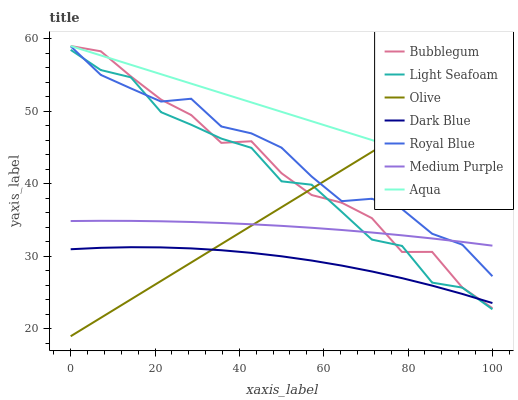Does Dark Blue have the minimum area under the curve?
Answer yes or no. Yes. Does Aqua have the maximum area under the curve?
Answer yes or no. Yes. Does Bubblegum have the minimum area under the curve?
Answer yes or no. No. Does Bubblegum have the maximum area under the curve?
Answer yes or no. No. Is Olive the smoothest?
Answer yes or no. Yes. Is Light Seafoam the roughest?
Answer yes or no. Yes. Is Aqua the smoothest?
Answer yes or no. No. Is Aqua the roughest?
Answer yes or no. No. Does Bubblegum have the lowest value?
Answer yes or no. No. Does Bubblegum have the highest value?
Answer yes or no. Yes. Does Medium Purple have the highest value?
Answer yes or no. No. Is Dark Blue less than Aqua?
Answer yes or no. Yes. Is Aqua greater than Light Seafoam?
Answer yes or no. Yes. Does Dark Blue intersect Aqua?
Answer yes or no. No. 